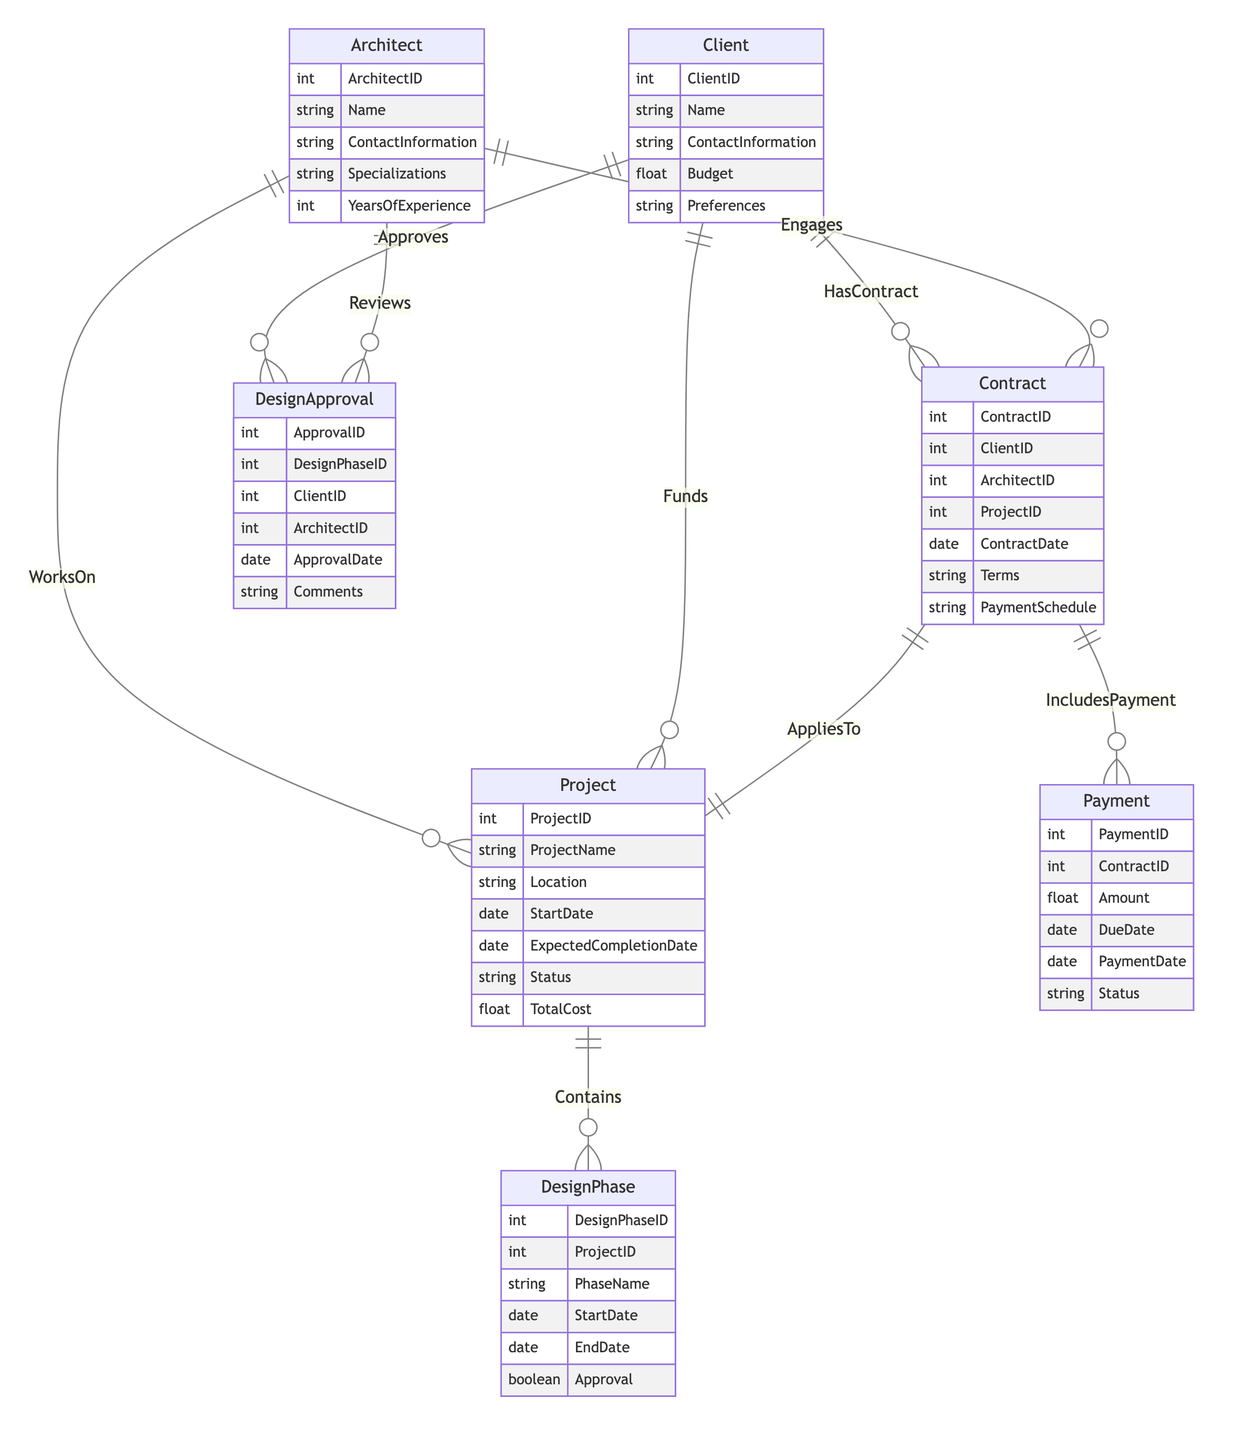What are the attributes of the Client entity? The Client entity has the following attributes: ClientID, Name, ContactInformation, Budget, Preferences. This can be determined by reviewing the entity listing in the diagram, where all attributes are defined under each entity.
Answer: ClientID, Name, ContactInformation, Budget, Preferences How many entities are there in total in the diagram? The diagram features six entities: Client, Architect, Project, DesignPhase, Contract, Payment, and DesignApproval. Therefore, by counting each unique entity specified, we arrive at this total.
Answer: Six What is the relationship between the Client and Contract entities called? The relationship is termed "HasContract," as indicated in the relationship lines connecting the Client entity to the Contract entity. Each relationship is labeled to clarify its nature.
Answer: HasContract How many payments can a single contract have? According to the relationship type defined, one contract can have multiple payments ("1:N"). This definition indicates that for every contract, there can be one or more associated payments.
Answer: One or more Which entity is primarily responsible for approving design phases? The Client entity is primarily responsible for approving design phases, as shown in the "Approves" relationship between Client and DesignApproval. This denotes that clients hold the authority to approve designs.
Answer: Client What do the "IncludesPayment" and "AppliesTo" relationships indicate? "IncludesPayment" indicates that multiple payments can be linked to a single contract, and "AppliesTo" indicates that each contract is associated with a single project. This shows how contracts manage financial aspects and their direct association with specific projects.
Answer: Financial management and project association How many design phases can a project contain? A project can contain multiple design phases, as shown by the "Contains" relationship defined as "1:N," indicating that one project can encompass numerous design phases while each design phase pertains to one specific project.
Answer: One or more What is the main purpose of the Contract entity? The main purpose of the Contract entity is to manage the terms of engagement between clients and architects for specific projects. This can be inferred as contracts formalize agreements and outline responsibilities, payment schedules, and terms of service.
Answer: Manage agreements Which role does the Architect play in the design approval process? The Architect plays the role of reviewer in the design approval process, as indicated by the "Reviews" relationship with the DesignApproval entity. This implies that architects evaluate and comment on the designs submitted for approval.
Answer: Reviewer 